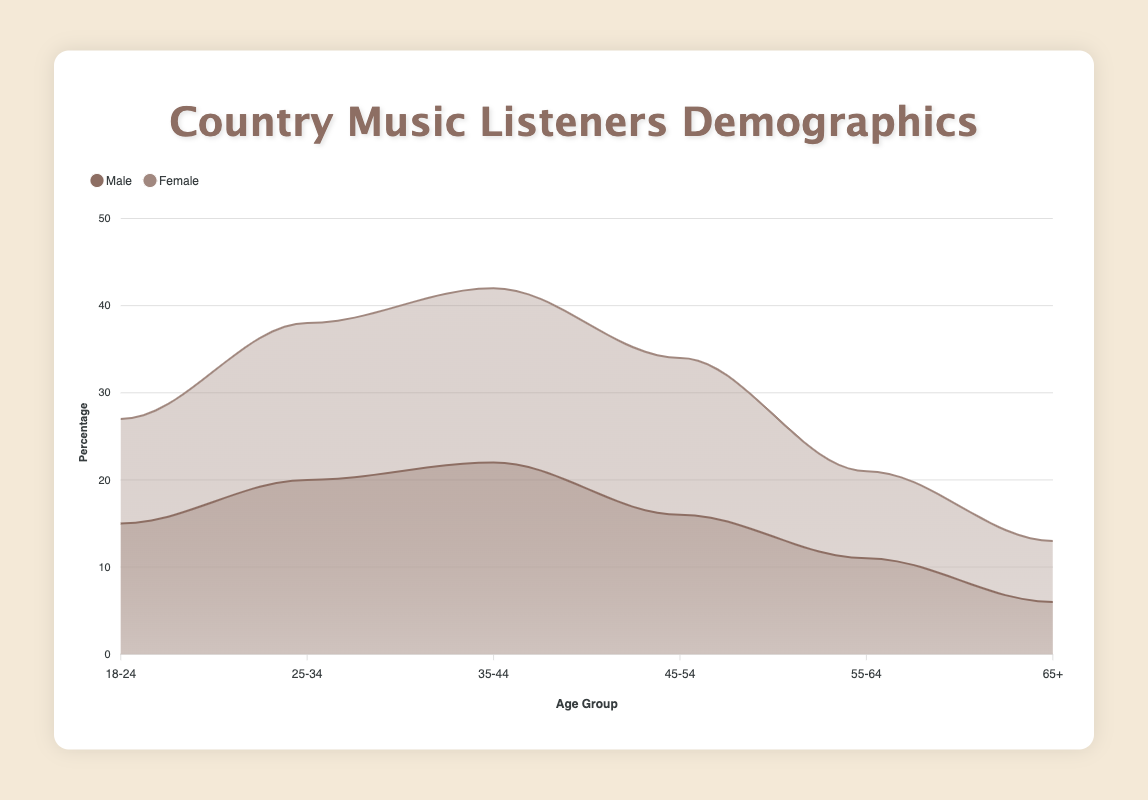What is the title of the chart? The title is located at the top of the chart and is usually used to give an overview of what the chart is about.
Answer: "Country Music Listeners Demographics" How many age groups are represented in the chart? The age groups are shown on the x-axis of the chart, which can be identified by reading each label. In total, there are six age groups.
Answer: 6 Which gender has a higher percentage of listeners in the age group 35-44? Look for the data points for the 35-44 age group, then compare the percentage values for male and female listeners in that age group.
Answer: Male Which age group has the lowest percentage of male listeners? By observing the male data series, identify the age group where the percentage value is the smallest.
Answer: 65+ What is the total percentage of female listeners in the age groups 45-54 and 55-64 combined? Sum up the percentage values of female listeners for the age groups 45-54 and 55-64: 18 + 10 = 28.
Answer: 28 Is there an age group where the percentage of female listeners is greater than that of male listeners? If so, which one? For each age group, compare the percentage values of male and female listeners to see if female listeners have a higher percentage.
Answer: 45-54 What is the percentage difference between male and female listeners in the age group 25-34? Subtract the percentage value of female listeners from that of male listeners in the 25-34 age group: 20 - 18 = 2.
Answer: 2 How does the trend of male listeners change from age group 18-24 to 35-44? Observing the male data series from age group 18-24 to 35-44, note whether the values are increasing, decreasing, or fluctuating.
Answer: Increasing Which age group has the most balanced gender distribution in terms of percentage difference? Calculate the difference between male and female percentages for each age group, and identify the age group with the smallest difference.
Answer: 55-64 How many gender series are there in the chart, and what are their colors? Count the number of individual gender series represented by different colors in the chart legend. The chart has two series, male and female, colored differently.
Answer: 2, brown and light brown 